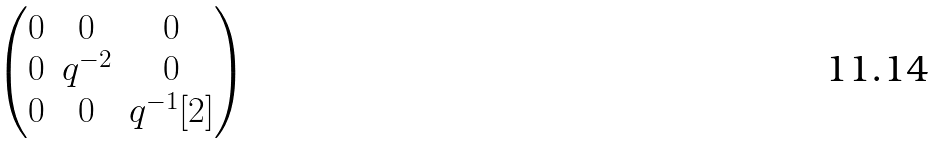Convert formula to latex. <formula><loc_0><loc_0><loc_500><loc_500>\begin{pmatrix} 0 & 0 & 0 \\ 0 & q ^ { - 2 } & 0 \\ 0 & 0 & q ^ { - 1 } [ 2 ] \end{pmatrix}</formula> 